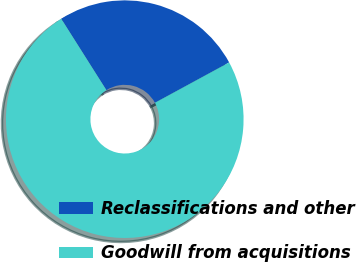Convert chart to OTSL. <chart><loc_0><loc_0><loc_500><loc_500><pie_chart><fcel>Reclassifications and other<fcel>Goodwill from acquisitions<nl><fcel>26.06%<fcel>73.94%<nl></chart> 